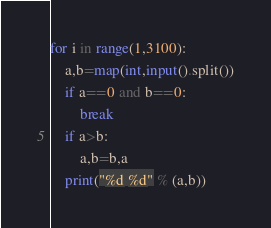<code> <loc_0><loc_0><loc_500><loc_500><_Python_>for i in range(1,3100):
    a,b=map(int,input().split())
    if a==0 and b==0:
        break
    if a>b:
        a,b=b,a
    print("%d %d" % (a,b))
</code> 